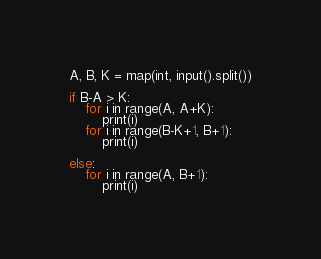Convert code to text. <code><loc_0><loc_0><loc_500><loc_500><_Python_>A, B, K = map(int, input().split())

if B-A > K:
    for i in range(A, A+K):
        print(i)
    for i in range(B-K+1, B+1):
        print(i)

else:
    for i in range(A, B+1):
        print(i)

</code> 